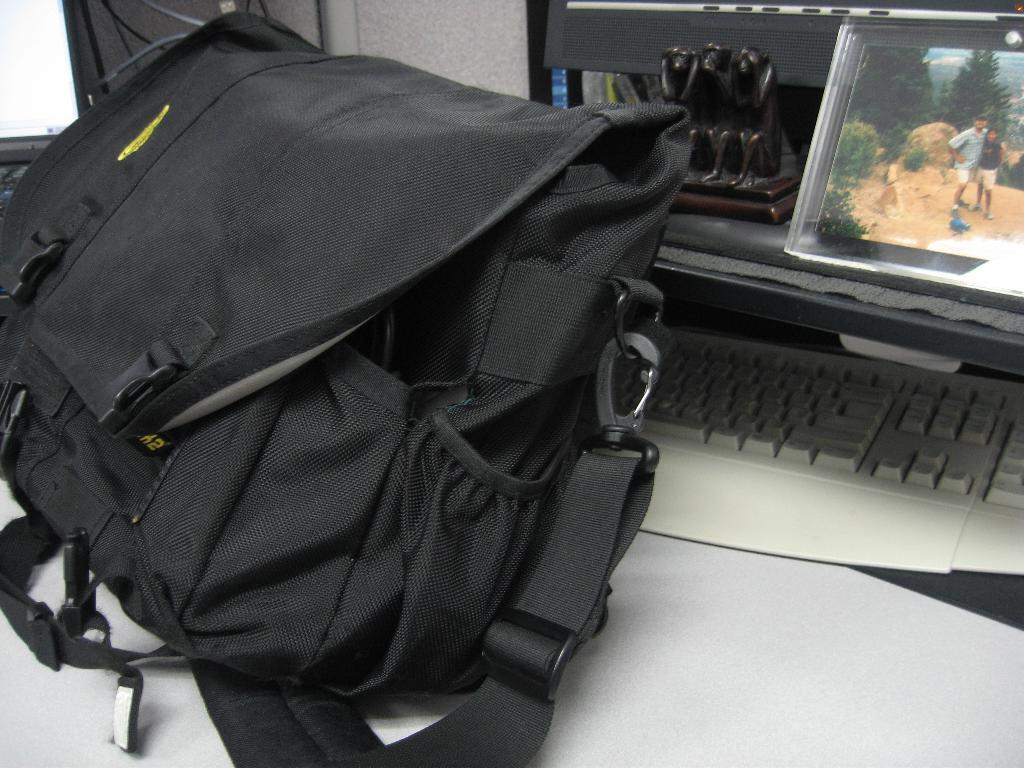What type of bag is in the image? There is a black color bag in the image. What electronic device is present in the image? There is a screen and a monitor in the image. What is used for typing in the image? There is a keyboard in the image. What type of art piece is in the image? There is a sculpture in the image. Where are all these objects located in the image? All these objects are on a table in the image. What type of team is depicted in the sculpture in the image? There is no team depicted in the sculpture in the image; it is a standalone art piece. What type of magic is being performed on the keyboard in the image? There is no magic being performed on the keyboard in the image; it is a standard input device for typing. 